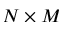Convert formula to latex. <formula><loc_0><loc_0><loc_500><loc_500>N \times M</formula> 